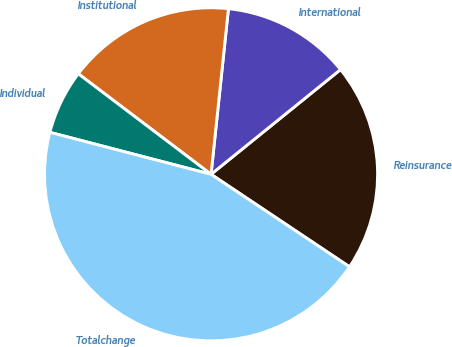Convert chart. <chart><loc_0><loc_0><loc_500><loc_500><pie_chart><fcel>Reinsurance<fcel>International<fcel>Institutional<fcel>Individual<fcel>Totalchange<nl><fcel>20.2%<fcel>12.51%<fcel>16.35%<fcel>6.26%<fcel>44.68%<nl></chart> 